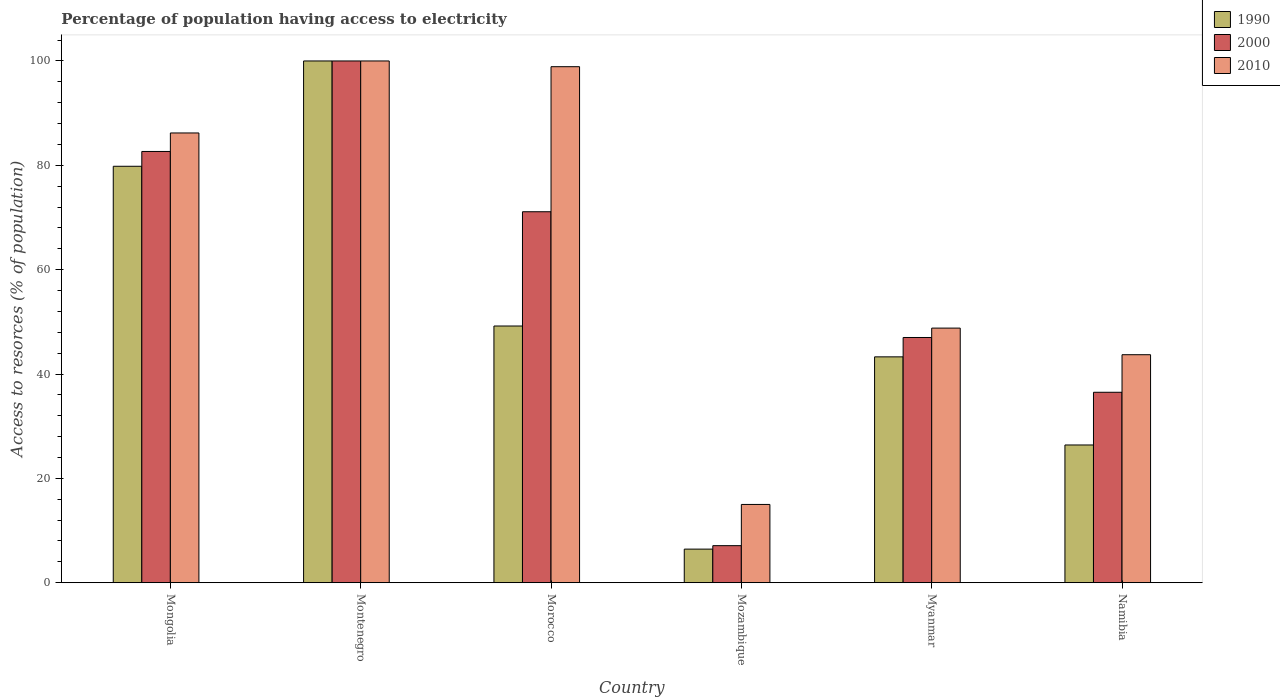How many groups of bars are there?
Your answer should be very brief. 6. Are the number of bars on each tick of the X-axis equal?
Make the answer very short. Yes. What is the label of the 6th group of bars from the left?
Offer a terse response. Namibia. What is the percentage of population having access to electricity in 1990 in Morocco?
Give a very brief answer. 49.2. In which country was the percentage of population having access to electricity in 2000 maximum?
Your answer should be very brief. Montenegro. In which country was the percentage of population having access to electricity in 2010 minimum?
Your answer should be compact. Mozambique. What is the total percentage of population having access to electricity in 2010 in the graph?
Provide a short and direct response. 392.6. What is the difference between the percentage of population having access to electricity in 1990 in Mongolia and that in Mozambique?
Ensure brevity in your answer.  73.38. What is the difference between the percentage of population having access to electricity in 1990 in Myanmar and the percentage of population having access to electricity in 2000 in Morocco?
Your response must be concise. -27.81. What is the average percentage of population having access to electricity in 2010 per country?
Your answer should be compact. 65.43. What is the difference between the percentage of population having access to electricity of/in 2010 and percentage of population having access to electricity of/in 2000 in Namibia?
Keep it short and to the point. 7.2. In how many countries, is the percentage of population having access to electricity in 1990 greater than 52 %?
Ensure brevity in your answer.  2. What is the ratio of the percentage of population having access to electricity in 2000 in Morocco to that in Myanmar?
Your answer should be compact. 1.51. Is the percentage of population having access to electricity in 2000 in Montenegro less than that in Mozambique?
Your answer should be compact. No. What is the difference between the highest and the second highest percentage of population having access to electricity in 2000?
Make the answer very short. -17.34. What is the difference between the highest and the lowest percentage of population having access to electricity in 1990?
Offer a terse response. 93.56. In how many countries, is the percentage of population having access to electricity in 1990 greater than the average percentage of population having access to electricity in 1990 taken over all countries?
Ensure brevity in your answer.  2. Is the sum of the percentage of population having access to electricity in 2000 in Montenegro and Mozambique greater than the maximum percentage of population having access to electricity in 1990 across all countries?
Your answer should be compact. Yes. Is it the case that in every country, the sum of the percentage of population having access to electricity in 2000 and percentage of population having access to electricity in 2010 is greater than the percentage of population having access to electricity in 1990?
Provide a succinct answer. Yes. Are all the bars in the graph horizontal?
Offer a terse response. No. How many countries are there in the graph?
Keep it short and to the point. 6. Are the values on the major ticks of Y-axis written in scientific E-notation?
Provide a short and direct response. No. Where does the legend appear in the graph?
Provide a short and direct response. Top right. How are the legend labels stacked?
Keep it short and to the point. Vertical. What is the title of the graph?
Offer a terse response. Percentage of population having access to electricity. Does "1972" appear as one of the legend labels in the graph?
Ensure brevity in your answer.  No. What is the label or title of the Y-axis?
Give a very brief answer. Access to resorces (% of population). What is the Access to resorces (% of population) of 1990 in Mongolia?
Your answer should be compact. 79.82. What is the Access to resorces (% of population) in 2000 in Mongolia?
Provide a short and direct response. 82.66. What is the Access to resorces (% of population) of 2010 in Mongolia?
Make the answer very short. 86.2. What is the Access to resorces (% of population) of 1990 in Morocco?
Your response must be concise. 49.2. What is the Access to resorces (% of population) of 2000 in Morocco?
Offer a terse response. 71.1. What is the Access to resorces (% of population) in 2010 in Morocco?
Provide a succinct answer. 98.9. What is the Access to resorces (% of population) of 1990 in Mozambique?
Your response must be concise. 6.44. What is the Access to resorces (% of population) of 2000 in Mozambique?
Provide a succinct answer. 7.1. What is the Access to resorces (% of population) in 2010 in Mozambique?
Give a very brief answer. 15. What is the Access to resorces (% of population) of 1990 in Myanmar?
Ensure brevity in your answer.  43.29. What is the Access to resorces (% of population) in 2010 in Myanmar?
Give a very brief answer. 48.8. What is the Access to resorces (% of population) of 1990 in Namibia?
Keep it short and to the point. 26.4. What is the Access to resorces (% of population) of 2000 in Namibia?
Make the answer very short. 36.5. What is the Access to resorces (% of population) in 2010 in Namibia?
Provide a short and direct response. 43.7. Across all countries, what is the maximum Access to resorces (% of population) in 2000?
Your answer should be very brief. 100. Across all countries, what is the maximum Access to resorces (% of population) of 2010?
Your answer should be very brief. 100. Across all countries, what is the minimum Access to resorces (% of population) in 1990?
Your response must be concise. 6.44. Across all countries, what is the minimum Access to resorces (% of population) in 2000?
Offer a terse response. 7.1. Across all countries, what is the minimum Access to resorces (% of population) of 2010?
Keep it short and to the point. 15. What is the total Access to resorces (% of population) of 1990 in the graph?
Offer a very short reply. 305.14. What is the total Access to resorces (% of population) in 2000 in the graph?
Offer a terse response. 344.36. What is the total Access to resorces (% of population) of 2010 in the graph?
Provide a succinct answer. 392.6. What is the difference between the Access to resorces (% of population) in 1990 in Mongolia and that in Montenegro?
Offer a terse response. -20.18. What is the difference between the Access to resorces (% of population) of 2000 in Mongolia and that in Montenegro?
Your answer should be very brief. -17.34. What is the difference between the Access to resorces (% of population) in 2010 in Mongolia and that in Montenegro?
Provide a short and direct response. -13.8. What is the difference between the Access to resorces (% of population) in 1990 in Mongolia and that in Morocco?
Your answer should be very brief. 30.62. What is the difference between the Access to resorces (% of population) of 2000 in Mongolia and that in Morocco?
Offer a very short reply. 11.56. What is the difference between the Access to resorces (% of population) in 1990 in Mongolia and that in Mozambique?
Make the answer very short. 73.38. What is the difference between the Access to resorces (% of population) in 2000 in Mongolia and that in Mozambique?
Keep it short and to the point. 75.56. What is the difference between the Access to resorces (% of population) of 2010 in Mongolia and that in Mozambique?
Your answer should be very brief. 71.2. What is the difference between the Access to resorces (% of population) of 1990 in Mongolia and that in Myanmar?
Make the answer very short. 36.53. What is the difference between the Access to resorces (% of population) of 2000 in Mongolia and that in Myanmar?
Your response must be concise. 35.66. What is the difference between the Access to resorces (% of population) in 2010 in Mongolia and that in Myanmar?
Your answer should be compact. 37.4. What is the difference between the Access to resorces (% of population) of 1990 in Mongolia and that in Namibia?
Your response must be concise. 53.42. What is the difference between the Access to resorces (% of population) of 2000 in Mongolia and that in Namibia?
Ensure brevity in your answer.  46.16. What is the difference between the Access to resorces (% of population) in 2010 in Mongolia and that in Namibia?
Give a very brief answer. 42.5. What is the difference between the Access to resorces (% of population) of 1990 in Montenegro and that in Morocco?
Give a very brief answer. 50.8. What is the difference between the Access to resorces (% of population) in 2000 in Montenegro and that in Morocco?
Keep it short and to the point. 28.9. What is the difference between the Access to resorces (% of population) of 1990 in Montenegro and that in Mozambique?
Your answer should be compact. 93.56. What is the difference between the Access to resorces (% of population) of 2000 in Montenegro and that in Mozambique?
Provide a short and direct response. 92.9. What is the difference between the Access to resorces (% of population) of 1990 in Montenegro and that in Myanmar?
Ensure brevity in your answer.  56.71. What is the difference between the Access to resorces (% of population) in 2000 in Montenegro and that in Myanmar?
Your answer should be compact. 53. What is the difference between the Access to resorces (% of population) of 2010 in Montenegro and that in Myanmar?
Your response must be concise. 51.2. What is the difference between the Access to resorces (% of population) in 1990 in Montenegro and that in Namibia?
Your response must be concise. 73.6. What is the difference between the Access to resorces (% of population) of 2000 in Montenegro and that in Namibia?
Make the answer very short. 63.5. What is the difference between the Access to resorces (% of population) in 2010 in Montenegro and that in Namibia?
Your response must be concise. 56.3. What is the difference between the Access to resorces (% of population) in 1990 in Morocco and that in Mozambique?
Provide a succinct answer. 42.76. What is the difference between the Access to resorces (% of population) of 2000 in Morocco and that in Mozambique?
Ensure brevity in your answer.  64. What is the difference between the Access to resorces (% of population) of 2010 in Morocco and that in Mozambique?
Offer a terse response. 83.9. What is the difference between the Access to resorces (% of population) of 1990 in Morocco and that in Myanmar?
Make the answer very short. 5.91. What is the difference between the Access to resorces (% of population) of 2000 in Morocco and that in Myanmar?
Give a very brief answer. 24.1. What is the difference between the Access to resorces (% of population) of 2010 in Morocco and that in Myanmar?
Your response must be concise. 50.1. What is the difference between the Access to resorces (% of population) of 1990 in Morocco and that in Namibia?
Offer a terse response. 22.8. What is the difference between the Access to resorces (% of population) of 2000 in Morocco and that in Namibia?
Your answer should be very brief. 34.6. What is the difference between the Access to resorces (% of population) in 2010 in Morocco and that in Namibia?
Offer a very short reply. 55.2. What is the difference between the Access to resorces (% of population) of 1990 in Mozambique and that in Myanmar?
Ensure brevity in your answer.  -36.85. What is the difference between the Access to resorces (% of population) of 2000 in Mozambique and that in Myanmar?
Provide a short and direct response. -39.9. What is the difference between the Access to resorces (% of population) in 2010 in Mozambique and that in Myanmar?
Your answer should be very brief. -33.8. What is the difference between the Access to resorces (% of population) in 1990 in Mozambique and that in Namibia?
Your answer should be very brief. -19.96. What is the difference between the Access to resorces (% of population) of 2000 in Mozambique and that in Namibia?
Your response must be concise. -29.4. What is the difference between the Access to resorces (% of population) in 2010 in Mozambique and that in Namibia?
Give a very brief answer. -28.7. What is the difference between the Access to resorces (% of population) in 1990 in Myanmar and that in Namibia?
Your answer should be compact. 16.89. What is the difference between the Access to resorces (% of population) in 1990 in Mongolia and the Access to resorces (% of population) in 2000 in Montenegro?
Offer a terse response. -20.18. What is the difference between the Access to resorces (% of population) in 1990 in Mongolia and the Access to resorces (% of population) in 2010 in Montenegro?
Ensure brevity in your answer.  -20.18. What is the difference between the Access to resorces (% of population) in 2000 in Mongolia and the Access to resorces (% of population) in 2010 in Montenegro?
Your answer should be compact. -17.34. What is the difference between the Access to resorces (% of population) in 1990 in Mongolia and the Access to resorces (% of population) in 2000 in Morocco?
Your answer should be compact. 8.72. What is the difference between the Access to resorces (% of population) of 1990 in Mongolia and the Access to resorces (% of population) of 2010 in Morocco?
Give a very brief answer. -19.08. What is the difference between the Access to resorces (% of population) of 2000 in Mongolia and the Access to resorces (% of population) of 2010 in Morocco?
Your answer should be very brief. -16.24. What is the difference between the Access to resorces (% of population) in 1990 in Mongolia and the Access to resorces (% of population) in 2000 in Mozambique?
Offer a terse response. 72.72. What is the difference between the Access to resorces (% of population) in 1990 in Mongolia and the Access to resorces (% of population) in 2010 in Mozambique?
Keep it short and to the point. 64.82. What is the difference between the Access to resorces (% of population) of 2000 in Mongolia and the Access to resorces (% of population) of 2010 in Mozambique?
Your answer should be very brief. 67.66. What is the difference between the Access to resorces (% of population) of 1990 in Mongolia and the Access to resorces (% of population) of 2000 in Myanmar?
Your answer should be compact. 32.82. What is the difference between the Access to resorces (% of population) in 1990 in Mongolia and the Access to resorces (% of population) in 2010 in Myanmar?
Give a very brief answer. 31.02. What is the difference between the Access to resorces (% of population) of 2000 in Mongolia and the Access to resorces (% of population) of 2010 in Myanmar?
Give a very brief answer. 33.86. What is the difference between the Access to resorces (% of population) in 1990 in Mongolia and the Access to resorces (% of population) in 2000 in Namibia?
Make the answer very short. 43.32. What is the difference between the Access to resorces (% of population) in 1990 in Mongolia and the Access to resorces (% of population) in 2010 in Namibia?
Make the answer very short. 36.12. What is the difference between the Access to resorces (% of population) in 2000 in Mongolia and the Access to resorces (% of population) in 2010 in Namibia?
Offer a terse response. 38.96. What is the difference between the Access to resorces (% of population) of 1990 in Montenegro and the Access to resorces (% of population) of 2000 in Morocco?
Your response must be concise. 28.9. What is the difference between the Access to resorces (% of population) in 2000 in Montenegro and the Access to resorces (% of population) in 2010 in Morocco?
Offer a terse response. 1.1. What is the difference between the Access to resorces (% of population) in 1990 in Montenegro and the Access to resorces (% of population) in 2000 in Mozambique?
Provide a succinct answer. 92.9. What is the difference between the Access to resorces (% of population) in 1990 in Montenegro and the Access to resorces (% of population) in 2010 in Mozambique?
Give a very brief answer. 85. What is the difference between the Access to resorces (% of population) in 2000 in Montenegro and the Access to resorces (% of population) in 2010 in Mozambique?
Provide a succinct answer. 85. What is the difference between the Access to resorces (% of population) in 1990 in Montenegro and the Access to resorces (% of population) in 2010 in Myanmar?
Provide a succinct answer. 51.2. What is the difference between the Access to resorces (% of population) in 2000 in Montenegro and the Access to resorces (% of population) in 2010 in Myanmar?
Provide a short and direct response. 51.2. What is the difference between the Access to resorces (% of population) of 1990 in Montenegro and the Access to resorces (% of population) of 2000 in Namibia?
Offer a terse response. 63.5. What is the difference between the Access to resorces (% of population) of 1990 in Montenegro and the Access to resorces (% of population) of 2010 in Namibia?
Give a very brief answer. 56.3. What is the difference between the Access to resorces (% of population) in 2000 in Montenegro and the Access to resorces (% of population) in 2010 in Namibia?
Offer a terse response. 56.3. What is the difference between the Access to resorces (% of population) of 1990 in Morocco and the Access to resorces (% of population) of 2000 in Mozambique?
Provide a short and direct response. 42.1. What is the difference between the Access to resorces (% of population) of 1990 in Morocco and the Access to resorces (% of population) of 2010 in Mozambique?
Your answer should be very brief. 34.2. What is the difference between the Access to resorces (% of population) in 2000 in Morocco and the Access to resorces (% of population) in 2010 in Mozambique?
Your response must be concise. 56.1. What is the difference between the Access to resorces (% of population) in 2000 in Morocco and the Access to resorces (% of population) in 2010 in Myanmar?
Provide a succinct answer. 22.3. What is the difference between the Access to resorces (% of population) in 1990 in Morocco and the Access to resorces (% of population) in 2000 in Namibia?
Provide a succinct answer. 12.7. What is the difference between the Access to resorces (% of population) in 1990 in Morocco and the Access to resorces (% of population) in 2010 in Namibia?
Offer a very short reply. 5.5. What is the difference between the Access to resorces (% of population) in 2000 in Morocco and the Access to resorces (% of population) in 2010 in Namibia?
Give a very brief answer. 27.4. What is the difference between the Access to resorces (% of population) of 1990 in Mozambique and the Access to resorces (% of population) of 2000 in Myanmar?
Provide a succinct answer. -40.56. What is the difference between the Access to resorces (% of population) of 1990 in Mozambique and the Access to resorces (% of population) of 2010 in Myanmar?
Make the answer very short. -42.36. What is the difference between the Access to resorces (% of population) in 2000 in Mozambique and the Access to resorces (% of population) in 2010 in Myanmar?
Your answer should be very brief. -41.7. What is the difference between the Access to resorces (% of population) of 1990 in Mozambique and the Access to resorces (% of population) of 2000 in Namibia?
Your response must be concise. -30.06. What is the difference between the Access to resorces (% of population) in 1990 in Mozambique and the Access to resorces (% of population) in 2010 in Namibia?
Provide a short and direct response. -37.26. What is the difference between the Access to resorces (% of population) of 2000 in Mozambique and the Access to resorces (% of population) of 2010 in Namibia?
Make the answer very short. -36.6. What is the difference between the Access to resorces (% of population) of 1990 in Myanmar and the Access to resorces (% of population) of 2000 in Namibia?
Keep it short and to the point. 6.79. What is the difference between the Access to resorces (% of population) in 1990 in Myanmar and the Access to resorces (% of population) in 2010 in Namibia?
Make the answer very short. -0.41. What is the difference between the Access to resorces (% of population) of 2000 in Myanmar and the Access to resorces (% of population) of 2010 in Namibia?
Offer a terse response. 3.3. What is the average Access to resorces (% of population) of 1990 per country?
Your response must be concise. 50.86. What is the average Access to resorces (% of population) of 2000 per country?
Your answer should be very brief. 57.39. What is the average Access to resorces (% of population) of 2010 per country?
Offer a very short reply. 65.43. What is the difference between the Access to resorces (% of population) in 1990 and Access to resorces (% of population) in 2000 in Mongolia?
Offer a terse response. -2.84. What is the difference between the Access to resorces (% of population) in 1990 and Access to resorces (% of population) in 2010 in Mongolia?
Your answer should be very brief. -6.38. What is the difference between the Access to resorces (% of population) of 2000 and Access to resorces (% of population) of 2010 in Mongolia?
Your answer should be very brief. -3.54. What is the difference between the Access to resorces (% of population) of 1990 and Access to resorces (% of population) of 2010 in Montenegro?
Give a very brief answer. 0. What is the difference between the Access to resorces (% of population) of 1990 and Access to resorces (% of population) of 2000 in Morocco?
Give a very brief answer. -21.9. What is the difference between the Access to resorces (% of population) in 1990 and Access to resorces (% of population) in 2010 in Morocco?
Provide a short and direct response. -49.7. What is the difference between the Access to resorces (% of population) of 2000 and Access to resorces (% of population) of 2010 in Morocco?
Your answer should be very brief. -27.8. What is the difference between the Access to resorces (% of population) in 1990 and Access to resorces (% of population) in 2000 in Mozambique?
Give a very brief answer. -0.66. What is the difference between the Access to resorces (% of population) in 1990 and Access to resorces (% of population) in 2010 in Mozambique?
Your response must be concise. -8.56. What is the difference between the Access to resorces (% of population) in 1990 and Access to resorces (% of population) in 2000 in Myanmar?
Your answer should be compact. -3.71. What is the difference between the Access to resorces (% of population) of 1990 and Access to resorces (% of population) of 2010 in Myanmar?
Keep it short and to the point. -5.51. What is the difference between the Access to resorces (% of population) in 2000 and Access to resorces (% of population) in 2010 in Myanmar?
Provide a short and direct response. -1.8. What is the difference between the Access to resorces (% of population) in 1990 and Access to resorces (% of population) in 2000 in Namibia?
Ensure brevity in your answer.  -10.1. What is the difference between the Access to resorces (% of population) of 1990 and Access to resorces (% of population) of 2010 in Namibia?
Offer a terse response. -17.3. What is the ratio of the Access to resorces (% of population) in 1990 in Mongolia to that in Montenegro?
Provide a succinct answer. 0.8. What is the ratio of the Access to resorces (% of population) in 2000 in Mongolia to that in Montenegro?
Your response must be concise. 0.83. What is the ratio of the Access to resorces (% of population) in 2010 in Mongolia to that in Montenegro?
Provide a succinct answer. 0.86. What is the ratio of the Access to resorces (% of population) of 1990 in Mongolia to that in Morocco?
Give a very brief answer. 1.62. What is the ratio of the Access to resorces (% of population) in 2000 in Mongolia to that in Morocco?
Give a very brief answer. 1.16. What is the ratio of the Access to resorces (% of population) of 2010 in Mongolia to that in Morocco?
Make the answer very short. 0.87. What is the ratio of the Access to resorces (% of population) in 1990 in Mongolia to that in Mozambique?
Provide a short and direct response. 12.4. What is the ratio of the Access to resorces (% of population) in 2000 in Mongolia to that in Mozambique?
Provide a succinct answer. 11.64. What is the ratio of the Access to resorces (% of population) in 2010 in Mongolia to that in Mozambique?
Your answer should be compact. 5.75. What is the ratio of the Access to resorces (% of population) in 1990 in Mongolia to that in Myanmar?
Provide a short and direct response. 1.84. What is the ratio of the Access to resorces (% of population) in 2000 in Mongolia to that in Myanmar?
Offer a very short reply. 1.76. What is the ratio of the Access to resorces (% of population) in 2010 in Mongolia to that in Myanmar?
Ensure brevity in your answer.  1.77. What is the ratio of the Access to resorces (% of population) in 1990 in Mongolia to that in Namibia?
Give a very brief answer. 3.02. What is the ratio of the Access to resorces (% of population) of 2000 in Mongolia to that in Namibia?
Give a very brief answer. 2.26. What is the ratio of the Access to resorces (% of population) in 2010 in Mongolia to that in Namibia?
Provide a short and direct response. 1.97. What is the ratio of the Access to resorces (% of population) in 1990 in Montenegro to that in Morocco?
Provide a short and direct response. 2.03. What is the ratio of the Access to resorces (% of population) in 2000 in Montenegro to that in Morocco?
Offer a very short reply. 1.41. What is the ratio of the Access to resorces (% of population) in 2010 in Montenegro to that in Morocco?
Offer a terse response. 1.01. What is the ratio of the Access to resorces (% of population) in 1990 in Montenegro to that in Mozambique?
Keep it short and to the point. 15.53. What is the ratio of the Access to resorces (% of population) in 2000 in Montenegro to that in Mozambique?
Offer a very short reply. 14.08. What is the ratio of the Access to resorces (% of population) of 2010 in Montenegro to that in Mozambique?
Give a very brief answer. 6.67. What is the ratio of the Access to resorces (% of population) in 1990 in Montenegro to that in Myanmar?
Your answer should be compact. 2.31. What is the ratio of the Access to resorces (% of population) in 2000 in Montenegro to that in Myanmar?
Ensure brevity in your answer.  2.13. What is the ratio of the Access to resorces (% of population) in 2010 in Montenegro to that in Myanmar?
Give a very brief answer. 2.05. What is the ratio of the Access to resorces (% of population) in 1990 in Montenegro to that in Namibia?
Offer a terse response. 3.79. What is the ratio of the Access to resorces (% of population) in 2000 in Montenegro to that in Namibia?
Offer a terse response. 2.74. What is the ratio of the Access to resorces (% of population) of 2010 in Montenegro to that in Namibia?
Offer a terse response. 2.29. What is the ratio of the Access to resorces (% of population) of 1990 in Morocco to that in Mozambique?
Your response must be concise. 7.64. What is the ratio of the Access to resorces (% of population) of 2000 in Morocco to that in Mozambique?
Offer a terse response. 10.01. What is the ratio of the Access to resorces (% of population) of 2010 in Morocco to that in Mozambique?
Ensure brevity in your answer.  6.59. What is the ratio of the Access to resorces (% of population) of 1990 in Morocco to that in Myanmar?
Ensure brevity in your answer.  1.14. What is the ratio of the Access to resorces (% of population) of 2000 in Morocco to that in Myanmar?
Ensure brevity in your answer.  1.51. What is the ratio of the Access to resorces (% of population) of 2010 in Morocco to that in Myanmar?
Provide a succinct answer. 2.03. What is the ratio of the Access to resorces (% of population) of 1990 in Morocco to that in Namibia?
Your answer should be compact. 1.86. What is the ratio of the Access to resorces (% of population) of 2000 in Morocco to that in Namibia?
Your response must be concise. 1.95. What is the ratio of the Access to resorces (% of population) in 2010 in Morocco to that in Namibia?
Your response must be concise. 2.26. What is the ratio of the Access to resorces (% of population) of 1990 in Mozambique to that in Myanmar?
Your response must be concise. 0.15. What is the ratio of the Access to resorces (% of population) of 2000 in Mozambique to that in Myanmar?
Your answer should be very brief. 0.15. What is the ratio of the Access to resorces (% of population) in 2010 in Mozambique to that in Myanmar?
Your answer should be very brief. 0.31. What is the ratio of the Access to resorces (% of population) of 1990 in Mozambique to that in Namibia?
Provide a succinct answer. 0.24. What is the ratio of the Access to resorces (% of population) in 2000 in Mozambique to that in Namibia?
Ensure brevity in your answer.  0.19. What is the ratio of the Access to resorces (% of population) in 2010 in Mozambique to that in Namibia?
Give a very brief answer. 0.34. What is the ratio of the Access to resorces (% of population) in 1990 in Myanmar to that in Namibia?
Your answer should be compact. 1.64. What is the ratio of the Access to resorces (% of population) in 2000 in Myanmar to that in Namibia?
Offer a terse response. 1.29. What is the ratio of the Access to resorces (% of population) of 2010 in Myanmar to that in Namibia?
Give a very brief answer. 1.12. What is the difference between the highest and the second highest Access to resorces (% of population) in 1990?
Offer a terse response. 20.18. What is the difference between the highest and the second highest Access to resorces (% of population) in 2000?
Provide a succinct answer. 17.34. What is the difference between the highest and the lowest Access to resorces (% of population) of 1990?
Offer a terse response. 93.56. What is the difference between the highest and the lowest Access to resorces (% of population) in 2000?
Your answer should be very brief. 92.9. What is the difference between the highest and the lowest Access to resorces (% of population) of 2010?
Give a very brief answer. 85. 